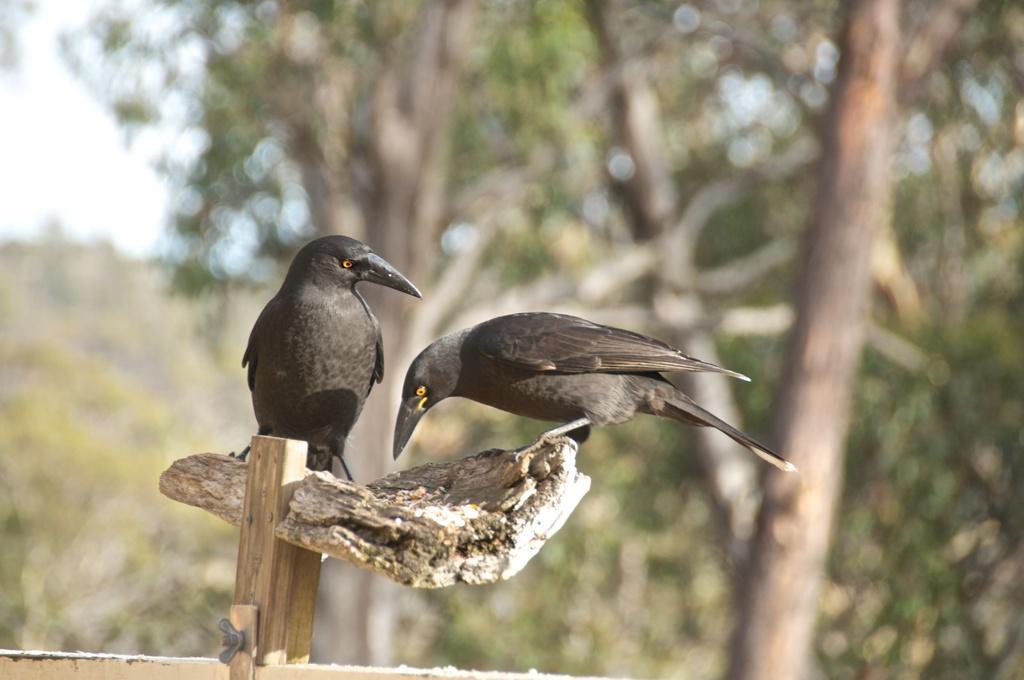Please provide a concise description of this image. In this image I can see two birds on the wooden surface. These birds are in black color. In the background there are many trees and the sky but it is blurry. 